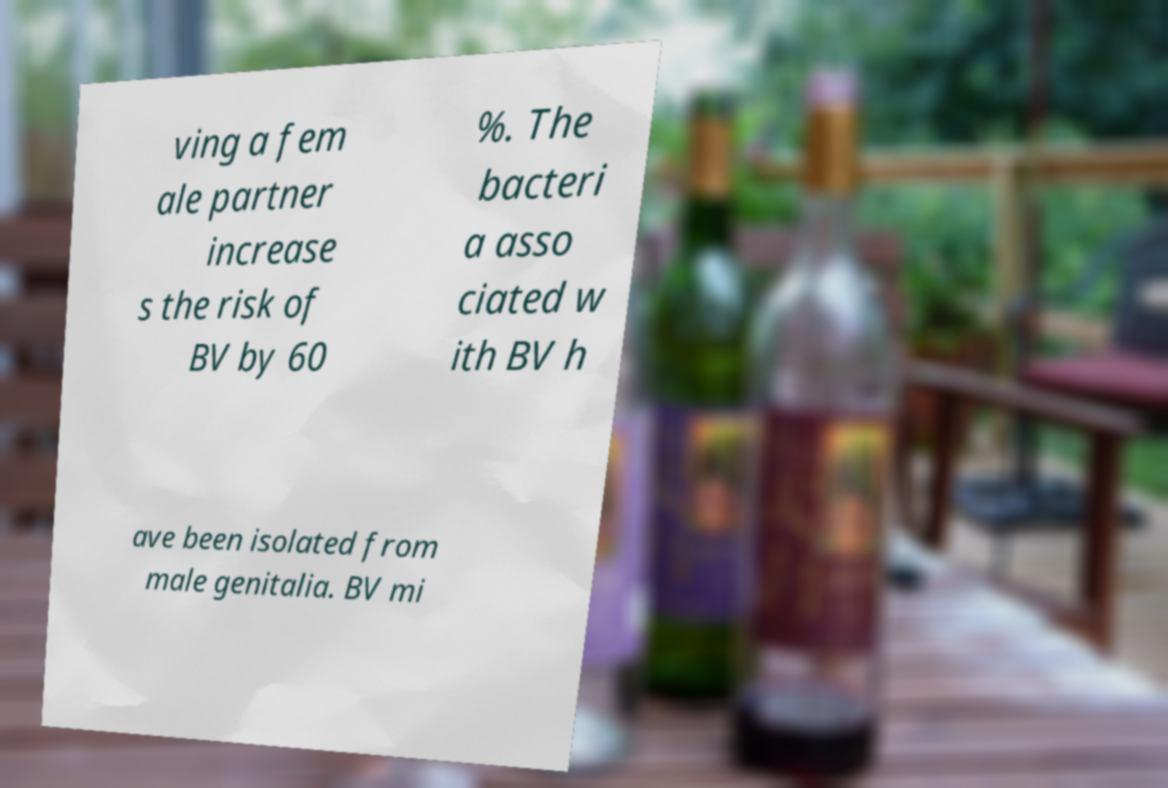Please identify and transcribe the text found in this image. ving a fem ale partner increase s the risk of BV by 60 %. The bacteri a asso ciated w ith BV h ave been isolated from male genitalia. BV mi 